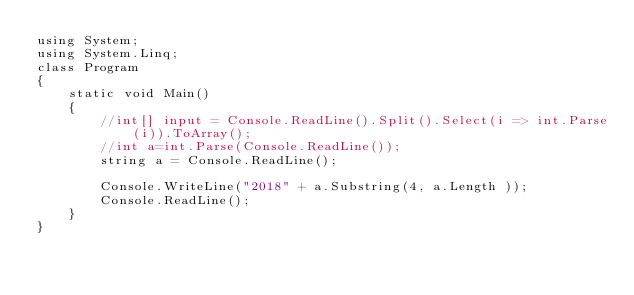Convert code to text. <code><loc_0><loc_0><loc_500><loc_500><_C#_>using System;
using System.Linq;
class Program
{
    static void Main()
    {
        //int[] input = Console.ReadLine().Split().Select(i => int.Parse(i)).ToArray(); 
        //int a=int.Parse(Console.ReadLine());
        string a = Console.ReadLine();

        Console.WriteLine("2018" + a.Substring(4, a.Length ));
        Console.ReadLine();
    }
}</code> 